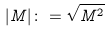Convert formula to latex. <formula><loc_0><loc_0><loc_500><loc_500>| M | \colon = \sqrt { M ^ { 2 } }</formula> 